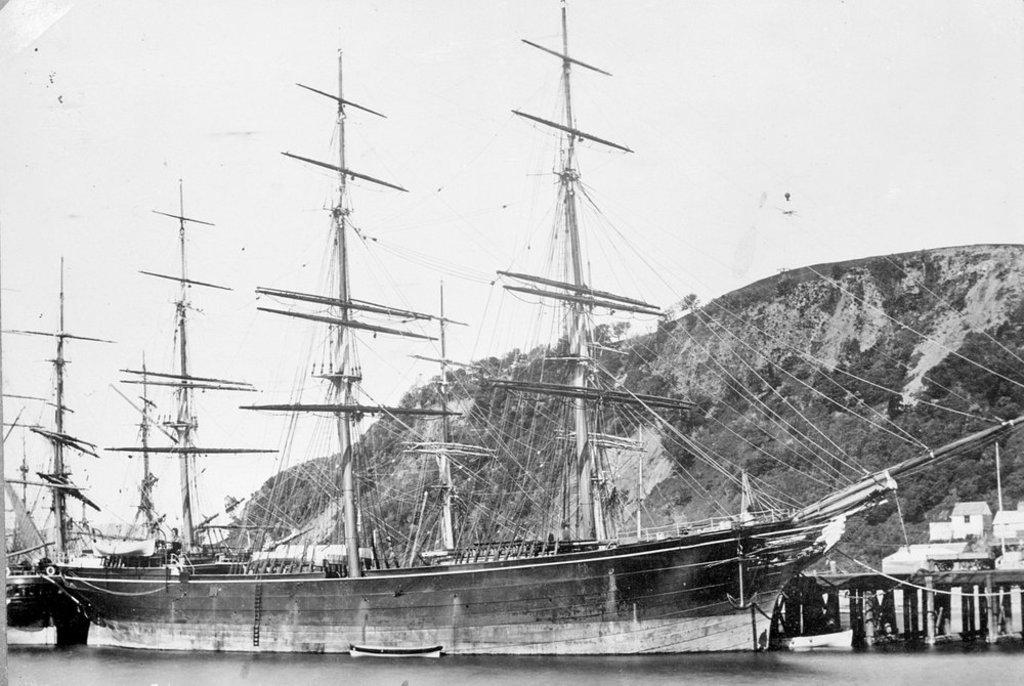What is the main subject in the center of the image? There are ships in the center of the image. What is located at the bottom of the image? There is water at the bottom of the image. What can be seen in the background of the image? The sky and a hill are visible in the background of the image. Can you tell me how many pets are on the ships in the image? There are no pets visible in the image; it features ships on water with a background of sky and a hill. 